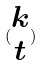Convert formula to latex. <formula><loc_0><loc_0><loc_500><loc_500>( \begin{matrix} k \\ t \end{matrix} )</formula> 